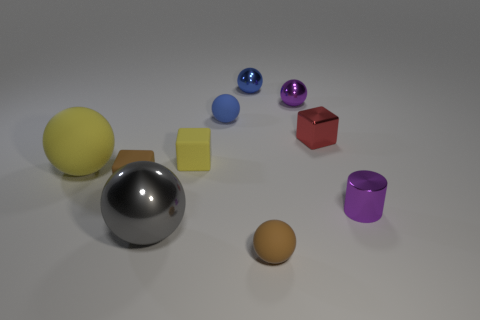Subtract all tiny brown balls. How many balls are left? 5 Subtract all brown cubes. How many cubes are left? 2 Subtract 3 blocks. How many blocks are left? 0 Subtract all purple spheres. How many brown blocks are left? 1 Subtract all small metal cubes. Subtract all tiny shiny things. How many objects are left? 5 Add 9 tiny brown balls. How many tiny brown balls are left? 10 Add 4 small blue matte objects. How many small blue matte objects exist? 5 Subtract 0 blue cylinders. How many objects are left? 10 Subtract all cylinders. How many objects are left? 9 Subtract all red cubes. Subtract all green spheres. How many cubes are left? 2 